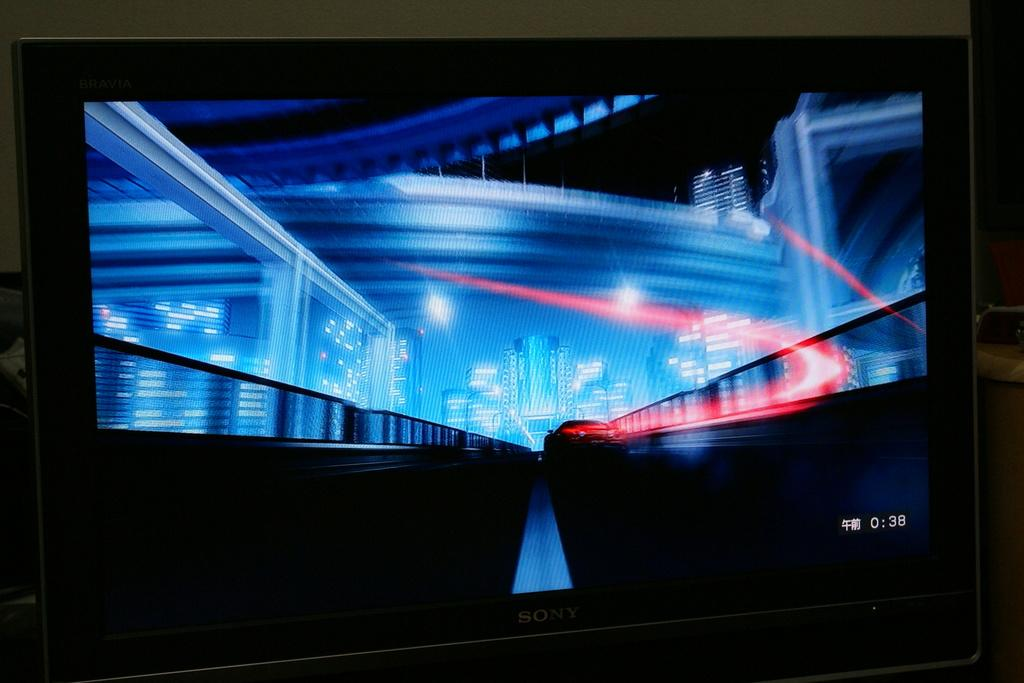Provide a one-sentence caption for the provided image. dark screen with blue and red patterns on it and 0:38 in the bottom right corner. 